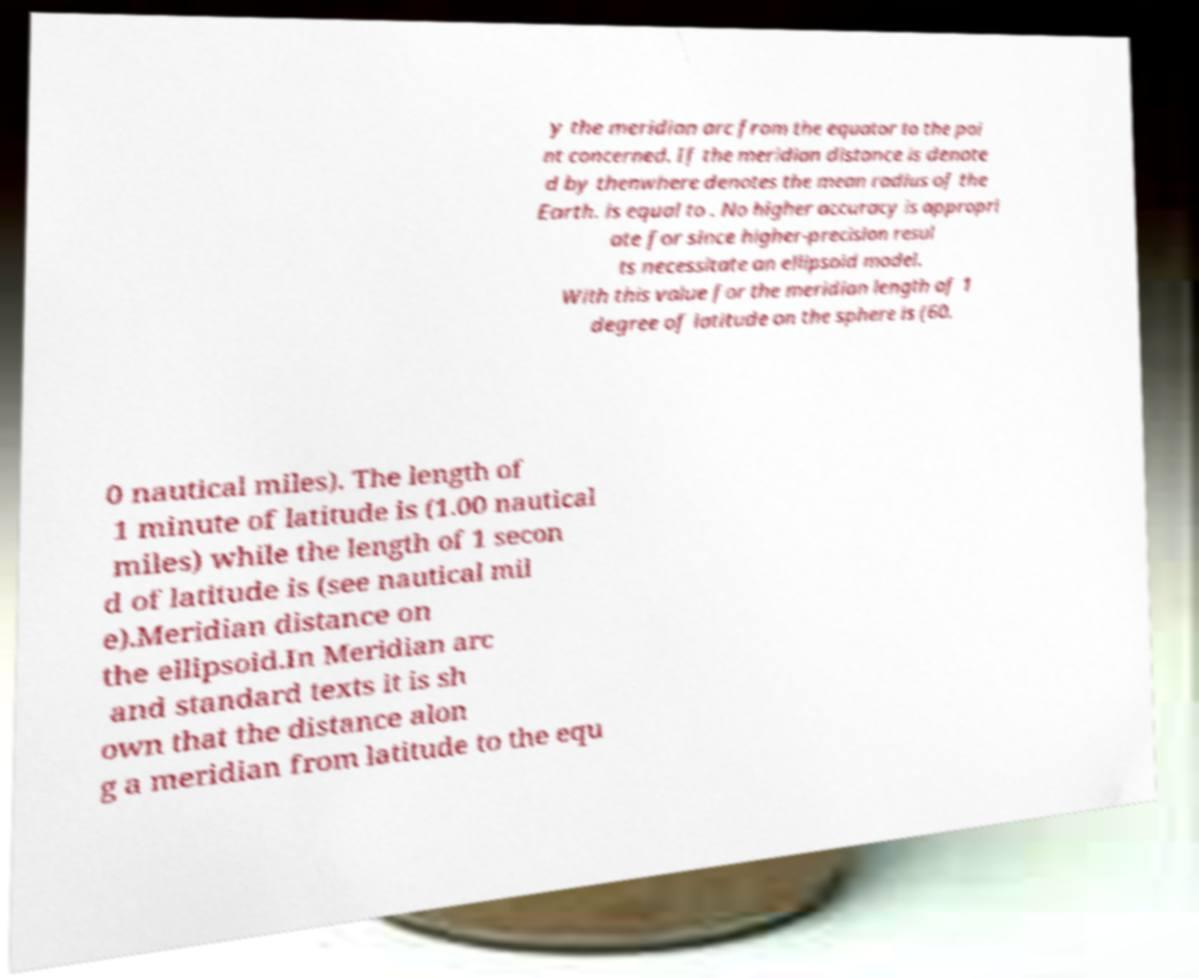Can you read and provide the text displayed in the image?This photo seems to have some interesting text. Can you extract and type it out for me? y the meridian arc from the equator to the poi nt concerned. If the meridian distance is denote d by thenwhere denotes the mean radius of the Earth. is equal to . No higher accuracy is appropri ate for since higher-precision resul ts necessitate an ellipsoid model. With this value for the meridian length of 1 degree of latitude on the sphere is (60. 0 nautical miles). The length of 1 minute of latitude is (1.00 nautical miles) while the length of 1 secon d of latitude is (see nautical mil e).Meridian distance on the ellipsoid.In Meridian arc and standard texts it is sh own that the distance alon g a meridian from latitude to the equ 